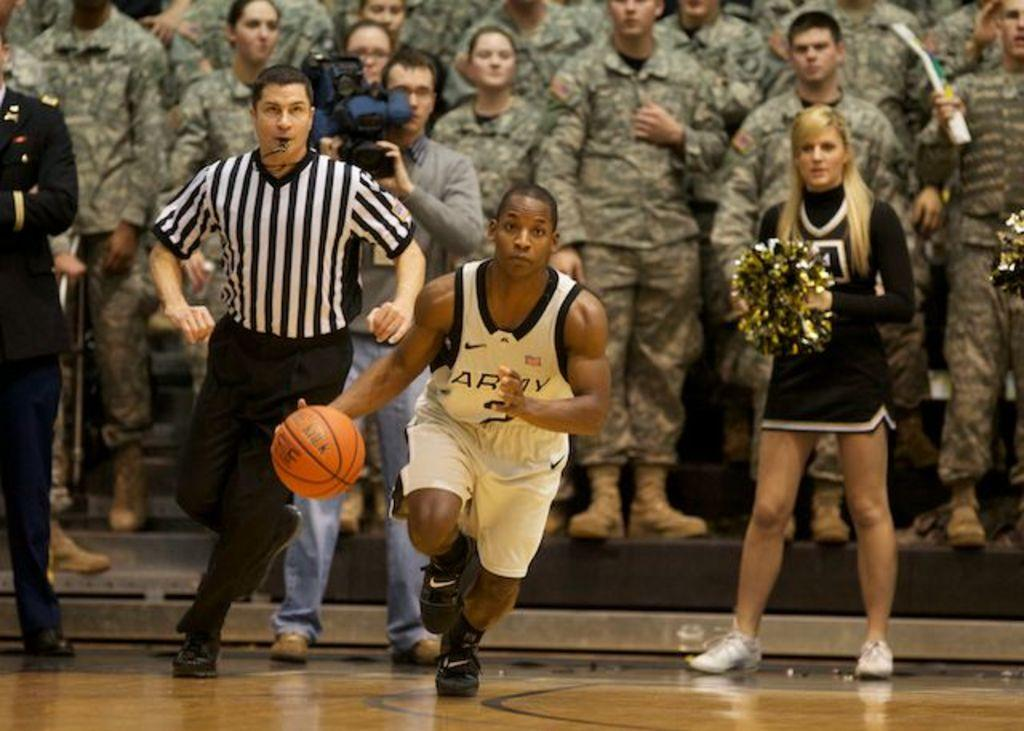What is the person in the image doing with the basketball? The person is running with a basketball in the image. Where is the person located in relation to the ground? The person is on the ground. What other individuals can be seen in the background of the image? There is a referee, a cameraman, cheer girls, and other persons in the background of the image. What type of brass instrument is being played by the person in the image? There is no brass instrument present in the image; the person is running with a basketball. What sound does the alarm make in the image? There is no alarm present in the image. 